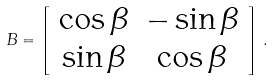<formula> <loc_0><loc_0><loc_500><loc_500>B = \left [ \begin{array} { c c } \cos \beta & - \sin \beta \\ \sin \beta & \cos \beta \end{array} \right ] \, .</formula> 